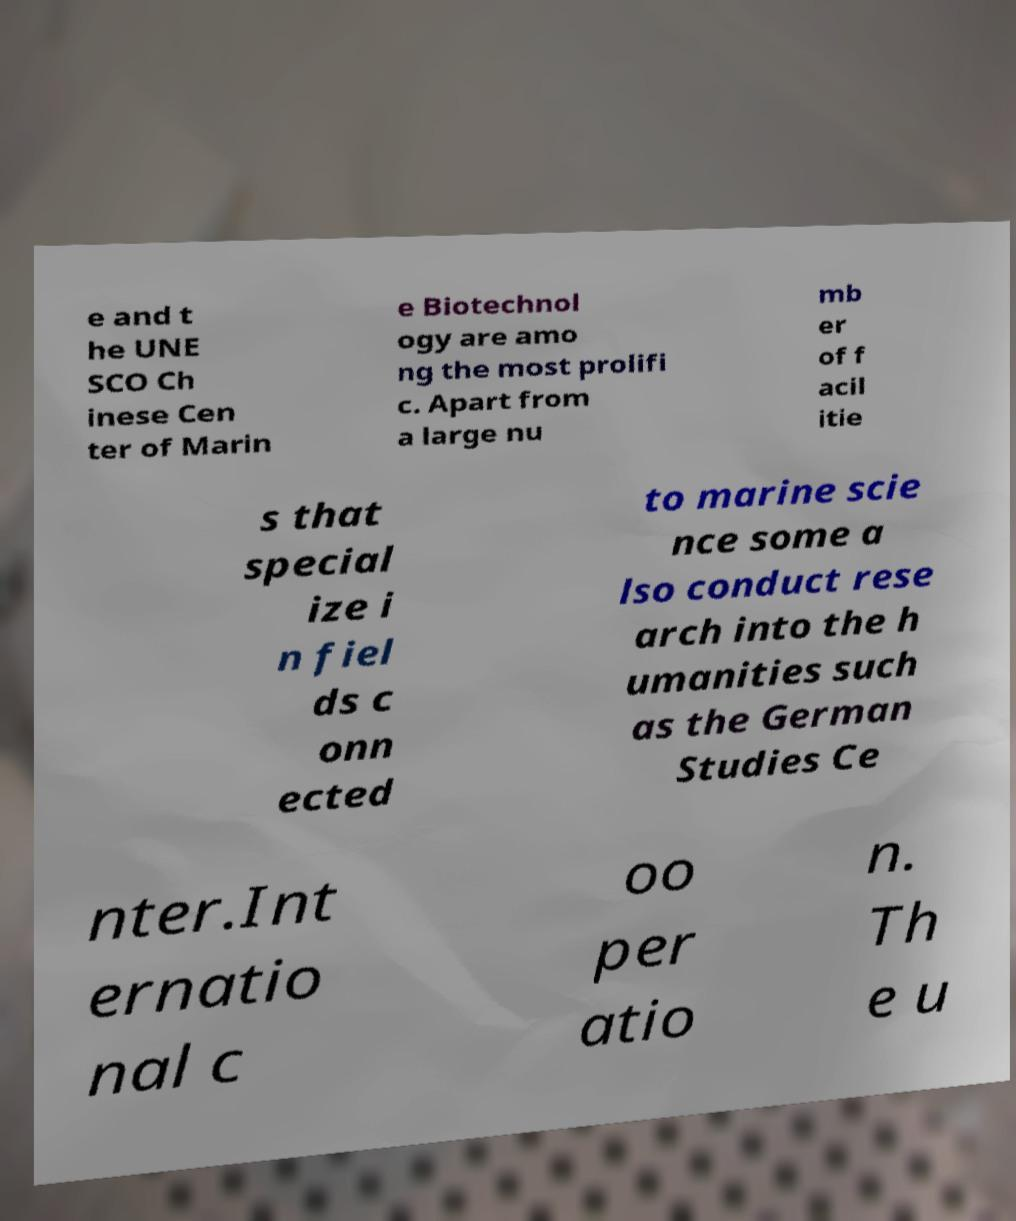Please identify and transcribe the text found in this image. e and t he UNE SCO Ch inese Cen ter of Marin e Biotechnol ogy are amo ng the most prolifi c. Apart from a large nu mb er of f acil itie s that special ize i n fiel ds c onn ected to marine scie nce some a lso conduct rese arch into the h umanities such as the German Studies Ce nter.Int ernatio nal c oo per atio n. Th e u 